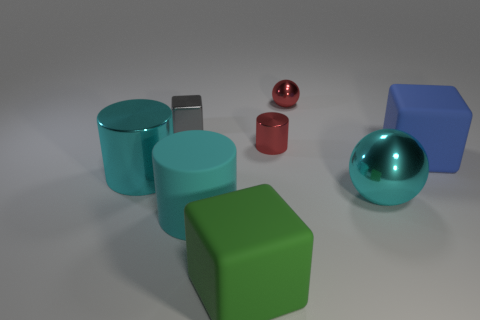Subtract 1 cylinders. How many cylinders are left? 2 Add 2 large cyan metallic things. How many objects exist? 10 Subtract all spheres. How many objects are left? 6 Subtract 0 gray spheres. How many objects are left? 8 Subtract all large cyan rubber objects. Subtract all large cyan balls. How many objects are left? 6 Add 3 blue things. How many blue things are left? 4 Add 5 big purple matte cubes. How many big purple matte cubes exist? 5 